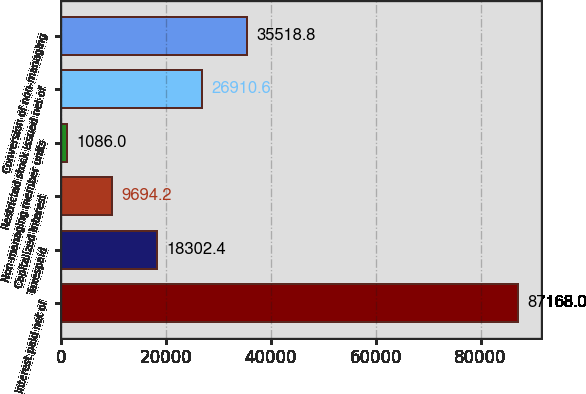Convert chart. <chart><loc_0><loc_0><loc_500><loc_500><bar_chart><fcel>Interest paid net of<fcel>Taxespaid<fcel>Capitalized interest<fcel>Non-managing member units<fcel>Restricted stock issued net of<fcel>Conversion of non-managing<nl><fcel>87168<fcel>18302.4<fcel>9694.2<fcel>1086<fcel>26910.6<fcel>35518.8<nl></chart> 